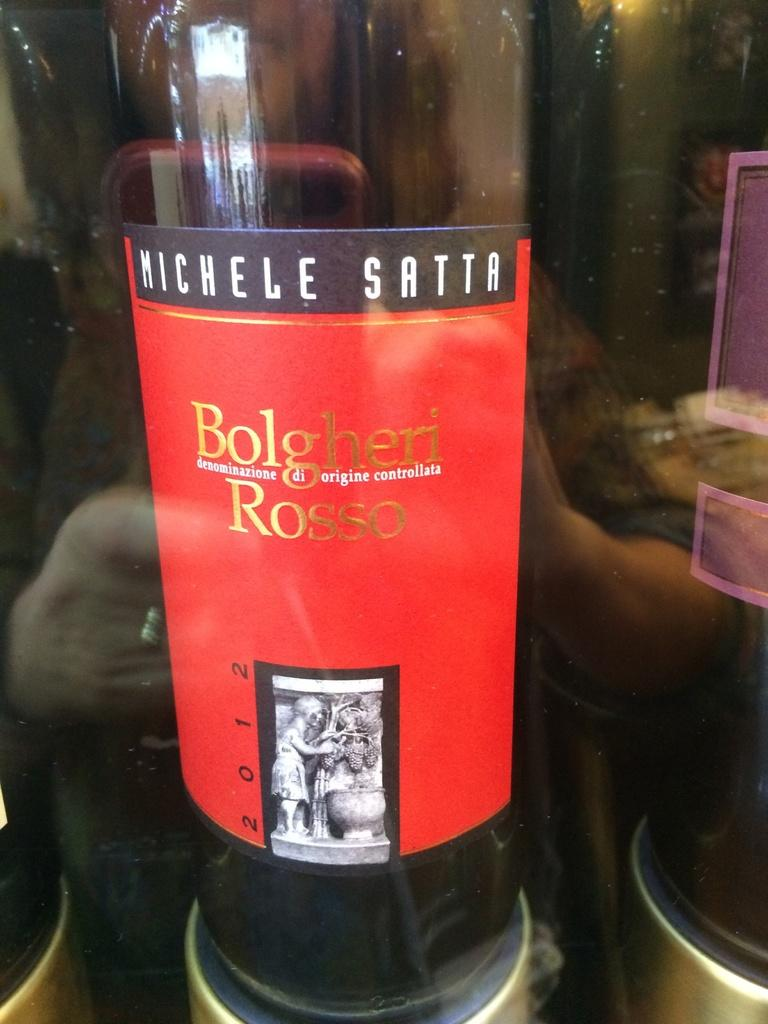What object can be seen in the image? There is a bottle in the image. What type of grape is used to create the design on the bottle in the image? There is no grape or design present on the bottle in the image. How many robins can be seen perched on the bottle in the image? There are no robins present in the image. 